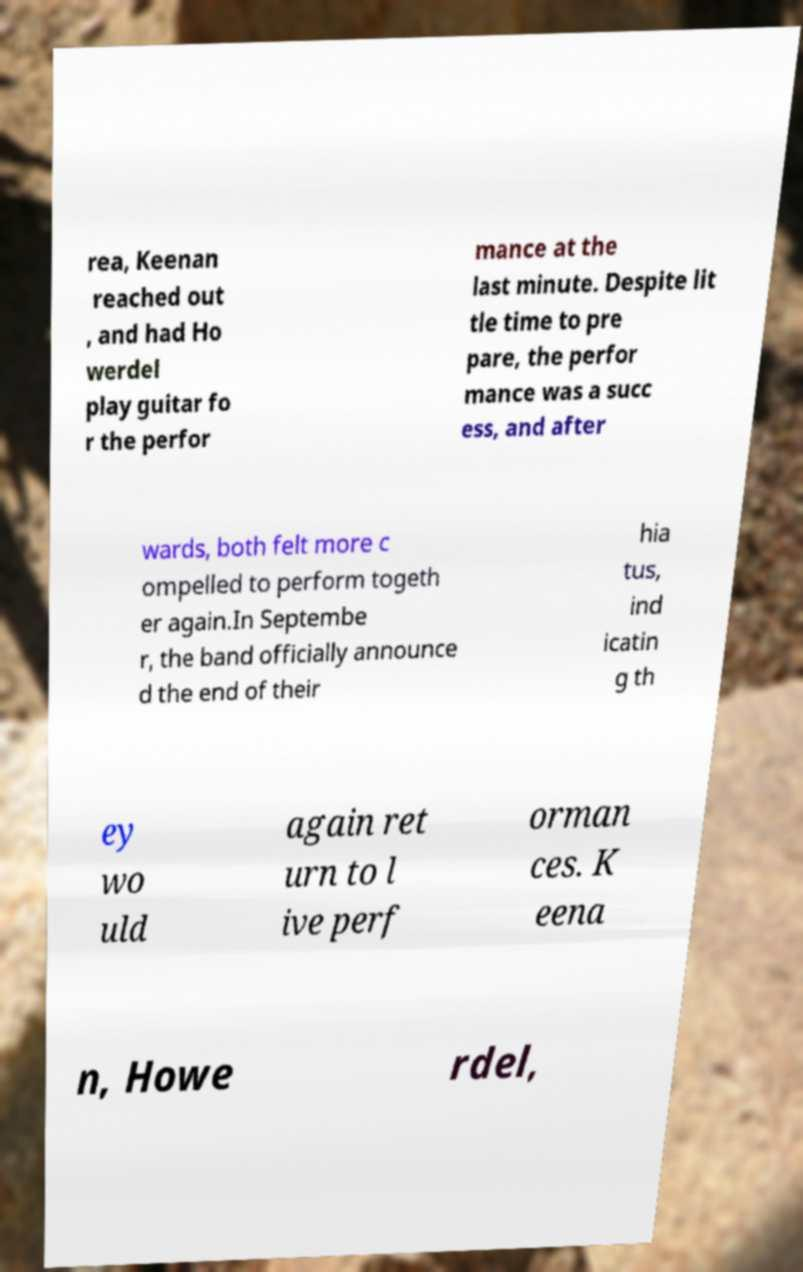For documentation purposes, I need the text within this image transcribed. Could you provide that? rea, Keenan reached out , and had Ho werdel play guitar fo r the perfor mance at the last minute. Despite lit tle time to pre pare, the perfor mance was a succ ess, and after wards, both felt more c ompelled to perform togeth er again.In Septembe r, the band officially announce d the end of their hia tus, ind icatin g th ey wo uld again ret urn to l ive perf orman ces. K eena n, Howe rdel, 